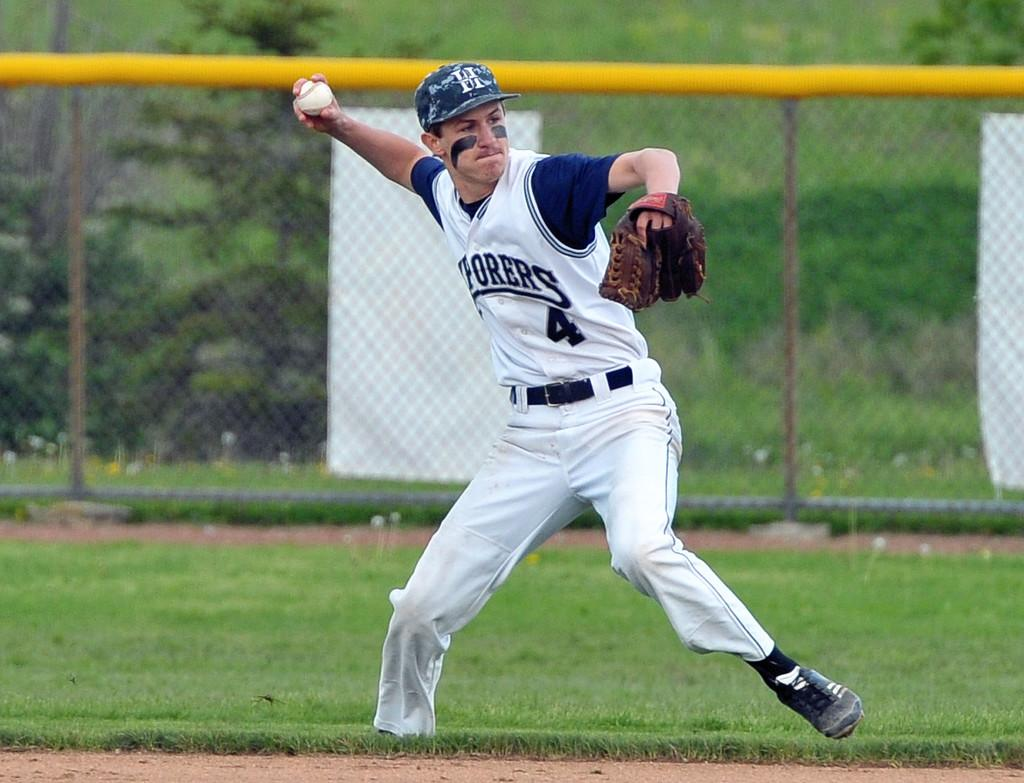<image>
Write a terse but informative summary of the picture. A baseball player on a field with number 4 on his shirt 